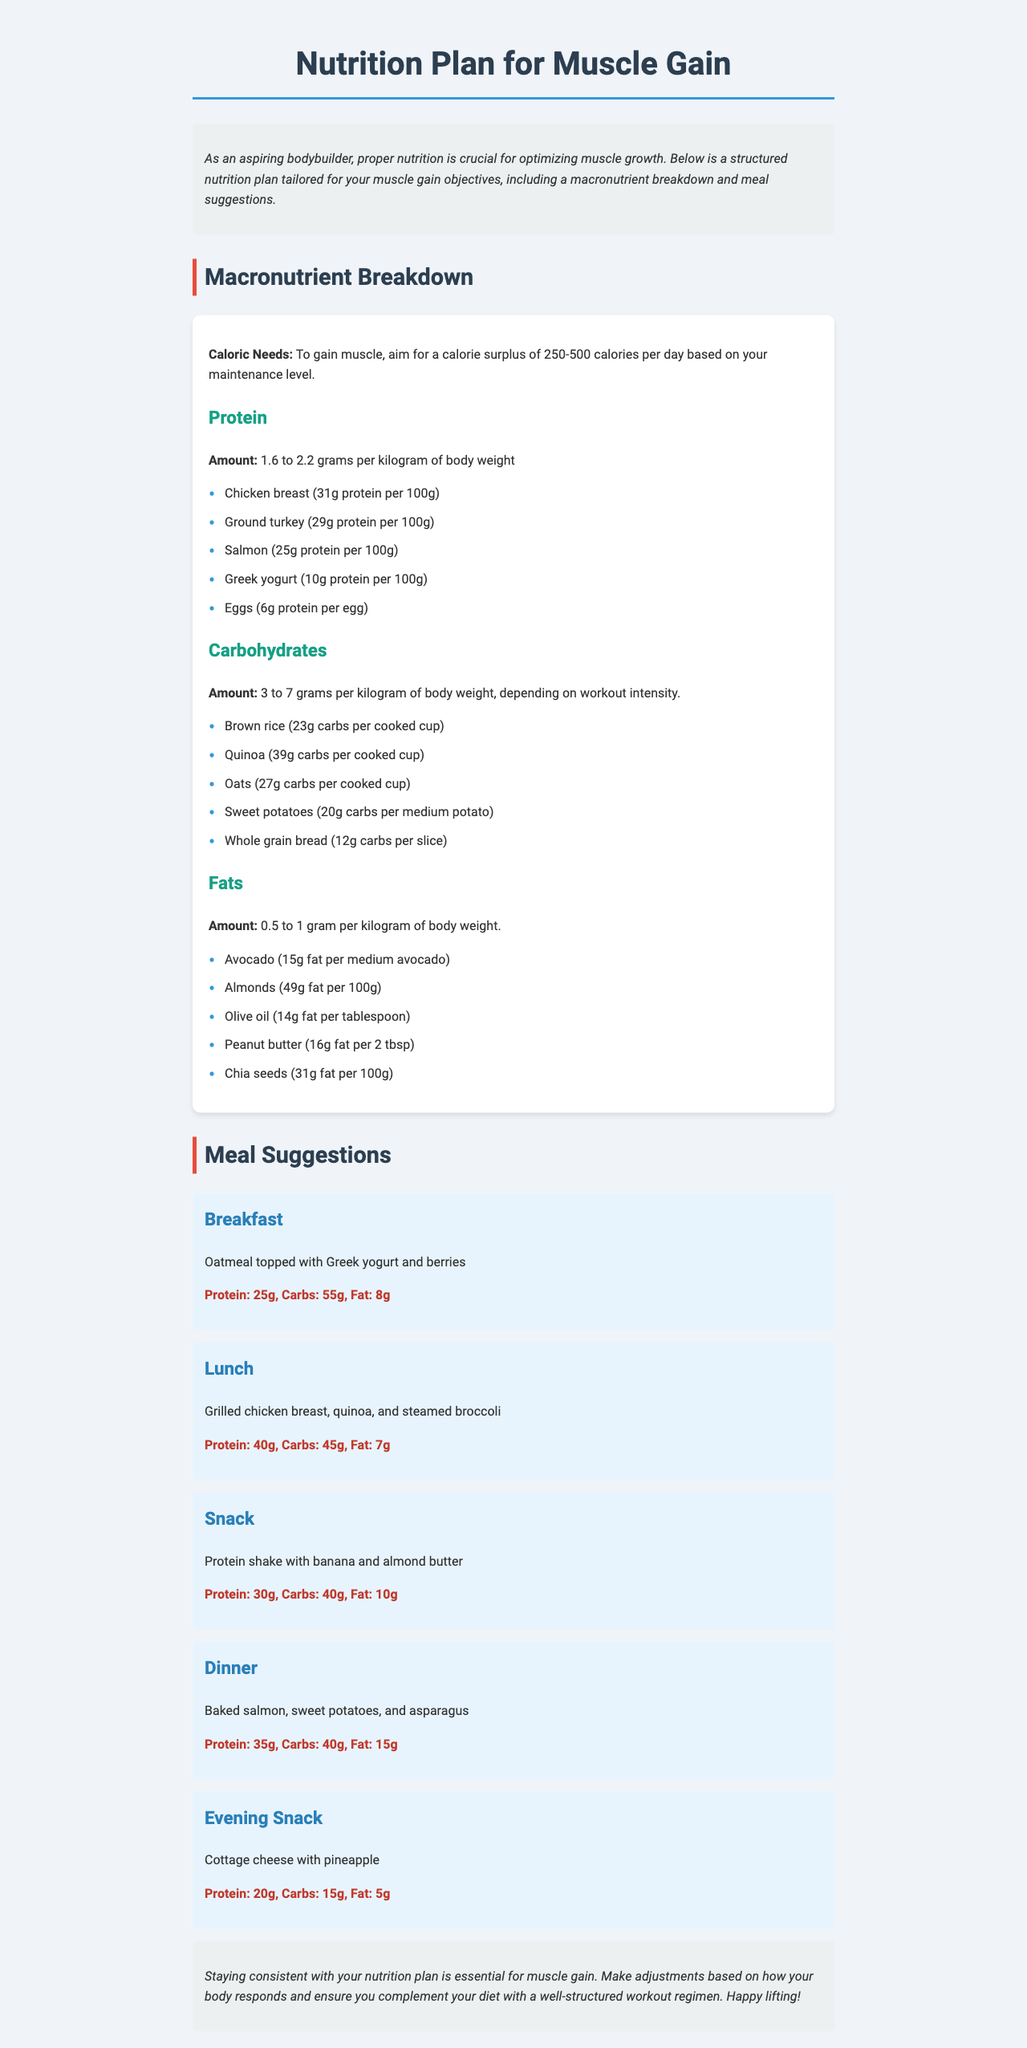What is the title of the document? The title is clearly stated at the top of the document, which is "Nutrition Plan for Muscle Gain."
Answer: Nutrition Plan for Muscle Gain What is the protein amount recommended per kilogram of body weight? The document specifies that the protein amount should be between 1.6 to 2.2 grams per kilogram of body weight.
Answer: 1.6 to 2.2 grams What is the carb content in one cup of oatmeal? The document lists that one cup of cooked oats contains 27 grams of carbohydrates.
Answer: 27 grams What is one of the suggested meals for dinner? The meal suggestions section includes "Baked salmon, sweet potatoes, and asparagus" for dinner.
Answer: Baked salmon, sweet potatoes, and asparagus How much fat does a medium avocado contain? The document states that a medium avocado contains 15 grams of fat.
Answer: 15 grams What should you do to adjust your nutrition plan? The conclusion suggests making adjustments based on how your body responds.
Answer: Make adjustments based on response What is the protein content in the evening snack? The document specifies that the evening snack consists of cottage cheese with pineapple, providing 20 grams of protein.
Answer: 20 grams What is the range of calorie surplus recommended for muscle gain? The document states that a calorie surplus of 250-500 calories per day is recommended based on maintenance levels.
Answer: 250-500 calories What type of document is this? The structure and contents indicate that it is a nutrition plan tailored to muscle gain for aspiring bodybuilders.
Answer: Nutrition plan 